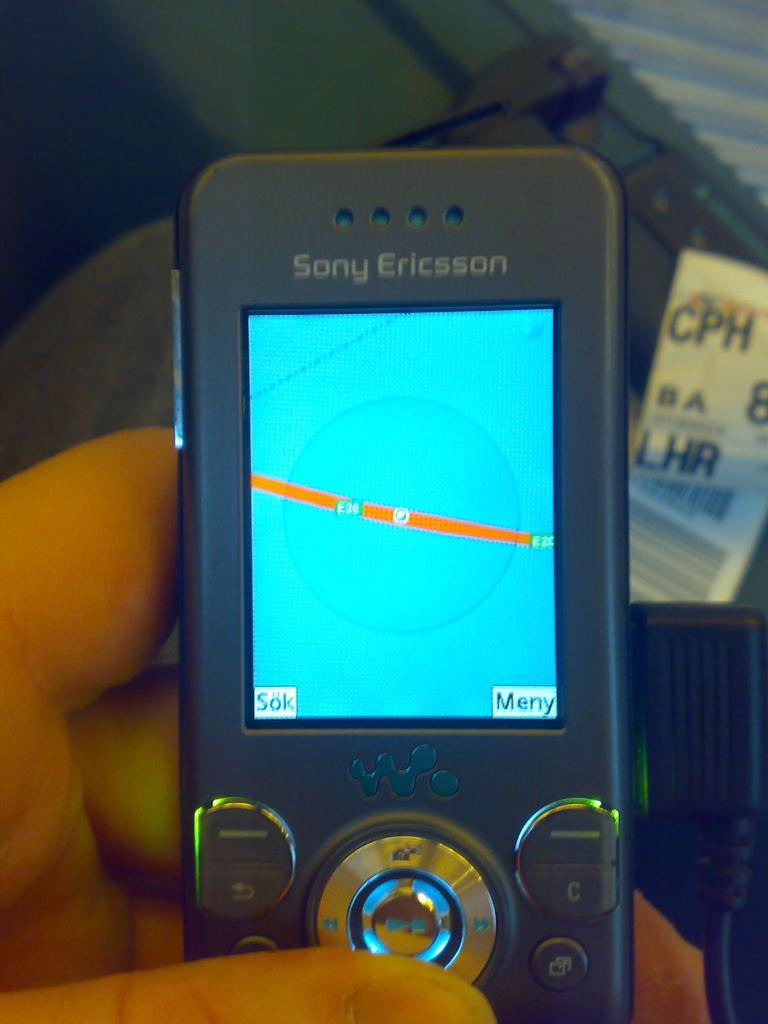What brand is this phone?
Offer a very short reply. Sony ericsson. What is the bottom right word on the phone?
Your answer should be very brief. Meny. 